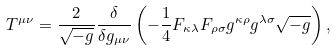Convert formula to latex. <formula><loc_0><loc_0><loc_500><loc_500>T ^ { \mu \nu } = \frac { 2 } { \sqrt { - g } } \frac { \delta } { \delta g _ { \mu \nu } } \left ( - \frac { 1 } { 4 } F _ { \kappa \lambda } F _ { \rho \sigma } g ^ { \kappa \rho } g ^ { \lambda \sigma } \sqrt { - g } \right ) ,</formula> 